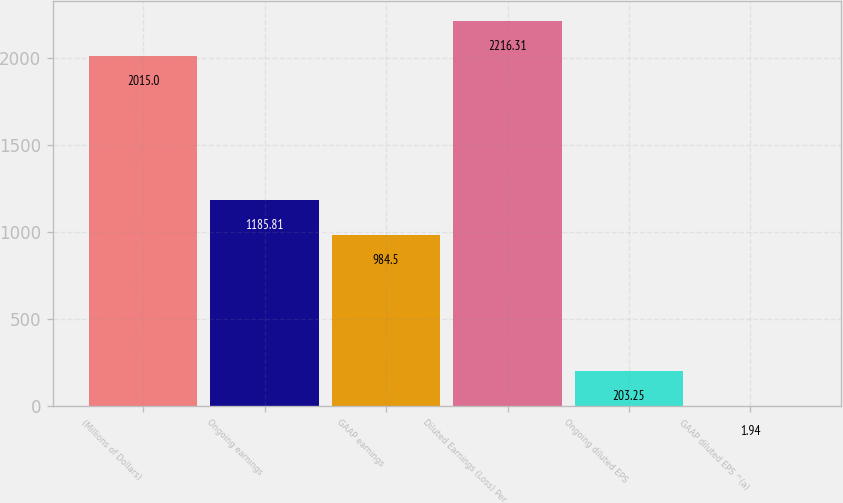Convert chart. <chart><loc_0><loc_0><loc_500><loc_500><bar_chart><fcel>(Millions of Dollars)<fcel>Ongoing earnings<fcel>GAAP earnings<fcel>Diluted Earnings (Loss) Per<fcel>Ongoing diluted EPS<fcel>GAAP diluted EPS ^(a)<nl><fcel>2015<fcel>1185.81<fcel>984.5<fcel>2216.31<fcel>203.25<fcel>1.94<nl></chart> 